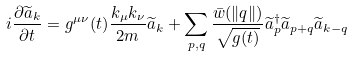<formula> <loc_0><loc_0><loc_500><loc_500>i \frac { \partial \widetilde { a } _ { k } } { \partial t } = g ^ { \mu \nu } ( t ) \frac { k _ { \mu } k _ { \nu } } { 2 m } \widetilde { a } _ { k } + \sum _ { p , q } \frac { \bar { w } ( \| { q } \| ) } { \sqrt { g ( t ) } } \widetilde { a } ^ { \dag } _ { p } \widetilde { a } _ { p + q } \widetilde { a } _ { k - q }</formula> 